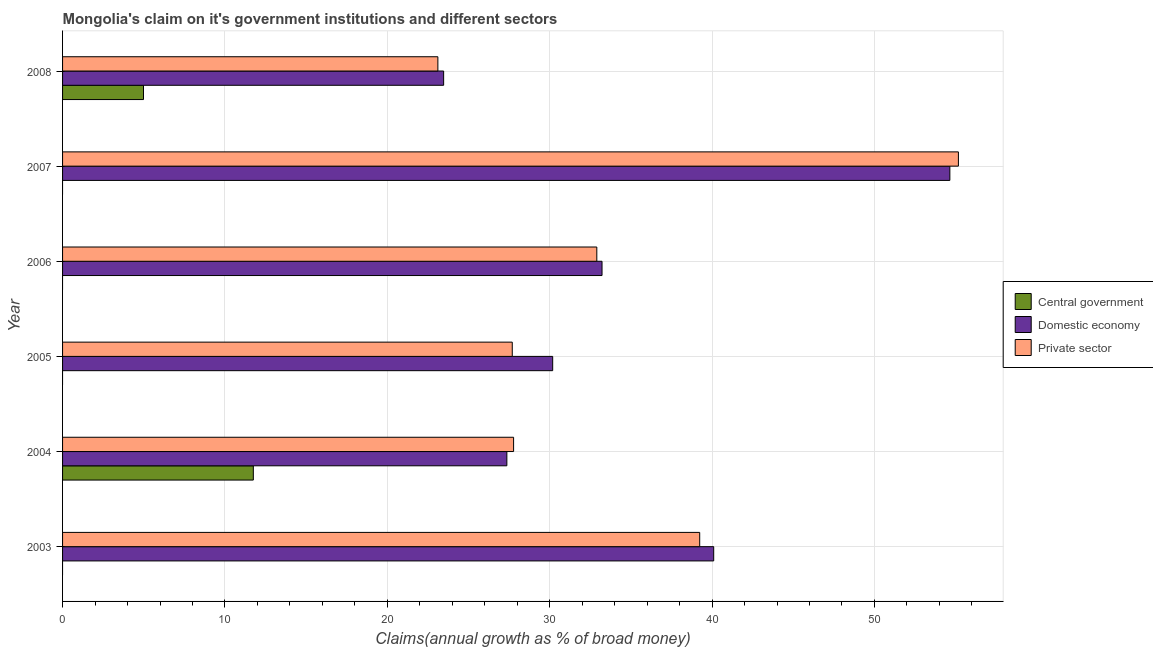How many different coloured bars are there?
Ensure brevity in your answer.  3. Are the number of bars per tick equal to the number of legend labels?
Your answer should be very brief. No. Are the number of bars on each tick of the Y-axis equal?
Your answer should be compact. No. How many bars are there on the 1st tick from the top?
Give a very brief answer. 3. How many bars are there on the 6th tick from the bottom?
Keep it short and to the point. 3. What is the label of the 3rd group of bars from the top?
Make the answer very short. 2006. What is the percentage of claim on the private sector in 2008?
Make the answer very short. 23.11. Across all years, what is the maximum percentage of claim on the central government?
Your answer should be compact. 11.75. Across all years, what is the minimum percentage of claim on the private sector?
Offer a terse response. 23.11. In which year was the percentage of claim on the domestic economy maximum?
Provide a succinct answer. 2007. What is the total percentage of claim on the central government in the graph?
Your answer should be compact. 16.73. What is the difference between the percentage of claim on the domestic economy in 2005 and that in 2008?
Ensure brevity in your answer.  6.71. What is the difference between the percentage of claim on the private sector in 2007 and the percentage of claim on the domestic economy in 2005?
Keep it short and to the point. 24.99. What is the average percentage of claim on the private sector per year?
Your answer should be compact. 34.32. In the year 2007, what is the difference between the percentage of claim on the private sector and percentage of claim on the domestic economy?
Your answer should be very brief. 0.53. In how many years, is the percentage of claim on the private sector greater than 8 %?
Keep it short and to the point. 6. What is the ratio of the percentage of claim on the domestic economy in 2003 to that in 2008?
Give a very brief answer. 1.71. What is the difference between the highest and the second highest percentage of claim on the private sector?
Offer a very short reply. 15.93. What is the difference between the highest and the lowest percentage of claim on the central government?
Ensure brevity in your answer.  11.75. Is it the case that in every year, the sum of the percentage of claim on the central government and percentage of claim on the domestic economy is greater than the percentage of claim on the private sector?
Your response must be concise. No. How many bars are there?
Ensure brevity in your answer.  14. Are all the bars in the graph horizontal?
Give a very brief answer. Yes. How many years are there in the graph?
Offer a very short reply. 6. Where does the legend appear in the graph?
Offer a terse response. Center right. How many legend labels are there?
Ensure brevity in your answer.  3. How are the legend labels stacked?
Give a very brief answer. Vertical. What is the title of the graph?
Offer a terse response. Mongolia's claim on it's government institutions and different sectors. Does "Grants" appear as one of the legend labels in the graph?
Your answer should be compact. No. What is the label or title of the X-axis?
Give a very brief answer. Claims(annual growth as % of broad money). What is the Claims(annual growth as % of broad money) of Domestic economy in 2003?
Your response must be concise. 40.1. What is the Claims(annual growth as % of broad money) in Private sector in 2003?
Your response must be concise. 39.24. What is the Claims(annual growth as % of broad money) in Central government in 2004?
Your answer should be very brief. 11.75. What is the Claims(annual growth as % of broad money) in Domestic economy in 2004?
Make the answer very short. 27.36. What is the Claims(annual growth as % of broad money) in Private sector in 2004?
Your response must be concise. 27.78. What is the Claims(annual growth as % of broad money) in Central government in 2005?
Provide a succinct answer. 0. What is the Claims(annual growth as % of broad money) in Domestic economy in 2005?
Offer a terse response. 30.18. What is the Claims(annual growth as % of broad money) of Private sector in 2005?
Your answer should be compact. 27.69. What is the Claims(annual growth as % of broad money) in Domestic economy in 2006?
Provide a short and direct response. 33.22. What is the Claims(annual growth as % of broad money) in Private sector in 2006?
Provide a succinct answer. 32.9. What is the Claims(annual growth as % of broad money) of Central government in 2007?
Provide a short and direct response. 0. What is the Claims(annual growth as % of broad money) in Domestic economy in 2007?
Your answer should be compact. 54.64. What is the Claims(annual growth as % of broad money) in Private sector in 2007?
Keep it short and to the point. 55.17. What is the Claims(annual growth as % of broad money) in Central government in 2008?
Give a very brief answer. 4.98. What is the Claims(annual growth as % of broad money) in Domestic economy in 2008?
Your response must be concise. 23.47. What is the Claims(annual growth as % of broad money) in Private sector in 2008?
Provide a succinct answer. 23.11. Across all years, what is the maximum Claims(annual growth as % of broad money) in Central government?
Provide a short and direct response. 11.75. Across all years, what is the maximum Claims(annual growth as % of broad money) of Domestic economy?
Your answer should be very brief. 54.64. Across all years, what is the maximum Claims(annual growth as % of broad money) of Private sector?
Make the answer very short. 55.17. Across all years, what is the minimum Claims(annual growth as % of broad money) of Domestic economy?
Keep it short and to the point. 23.47. Across all years, what is the minimum Claims(annual growth as % of broad money) of Private sector?
Your response must be concise. 23.11. What is the total Claims(annual growth as % of broad money) of Central government in the graph?
Provide a short and direct response. 16.73. What is the total Claims(annual growth as % of broad money) of Domestic economy in the graph?
Ensure brevity in your answer.  208.98. What is the total Claims(annual growth as % of broad money) in Private sector in the graph?
Provide a succinct answer. 205.89. What is the difference between the Claims(annual growth as % of broad money) of Domestic economy in 2003 and that in 2004?
Your answer should be very brief. 12.74. What is the difference between the Claims(annual growth as % of broad money) in Private sector in 2003 and that in 2004?
Provide a short and direct response. 11.46. What is the difference between the Claims(annual growth as % of broad money) of Domestic economy in 2003 and that in 2005?
Offer a terse response. 9.92. What is the difference between the Claims(annual growth as % of broad money) of Private sector in 2003 and that in 2005?
Make the answer very short. 11.54. What is the difference between the Claims(annual growth as % of broad money) of Domestic economy in 2003 and that in 2006?
Your response must be concise. 6.88. What is the difference between the Claims(annual growth as % of broad money) in Private sector in 2003 and that in 2006?
Your answer should be compact. 6.34. What is the difference between the Claims(annual growth as % of broad money) in Domestic economy in 2003 and that in 2007?
Your response must be concise. -14.54. What is the difference between the Claims(annual growth as % of broad money) of Private sector in 2003 and that in 2007?
Give a very brief answer. -15.93. What is the difference between the Claims(annual growth as % of broad money) in Domestic economy in 2003 and that in 2008?
Your response must be concise. 16.63. What is the difference between the Claims(annual growth as % of broad money) of Private sector in 2003 and that in 2008?
Give a very brief answer. 16.13. What is the difference between the Claims(annual growth as % of broad money) of Domestic economy in 2004 and that in 2005?
Provide a succinct answer. -2.82. What is the difference between the Claims(annual growth as % of broad money) in Private sector in 2004 and that in 2005?
Provide a succinct answer. 0.08. What is the difference between the Claims(annual growth as % of broad money) of Domestic economy in 2004 and that in 2006?
Give a very brief answer. -5.86. What is the difference between the Claims(annual growth as % of broad money) of Private sector in 2004 and that in 2006?
Offer a very short reply. -5.13. What is the difference between the Claims(annual growth as % of broad money) in Domestic economy in 2004 and that in 2007?
Provide a succinct answer. -27.28. What is the difference between the Claims(annual growth as % of broad money) of Private sector in 2004 and that in 2007?
Give a very brief answer. -27.39. What is the difference between the Claims(annual growth as % of broad money) of Central government in 2004 and that in 2008?
Your answer should be very brief. 6.76. What is the difference between the Claims(annual growth as % of broad money) of Domestic economy in 2004 and that in 2008?
Keep it short and to the point. 3.89. What is the difference between the Claims(annual growth as % of broad money) in Private sector in 2004 and that in 2008?
Your answer should be very brief. 4.66. What is the difference between the Claims(annual growth as % of broad money) of Domestic economy in 2005 and that in 2006?
Ensure brevity in your answer.  -3.04. What is the difference between the Claims(annual growth as % of broad money) in Private sector in 2005 and that in 2006?
Ensure brevity in your answer.  -5.21. What is the difference between the Claims(annual growth as % of broad money) in Domestic economy in 2005 and that in 2007?
Provide a short and direct response. -24.46. What is the difference between the Claims(annual growth as % of broad money) in Private sector in 2005 and that in 2007?
Your answer should be very brief. -27.48. What is the difference between the Claims(annual growth as % of broad money) in Domestic economy in 2005 and that in 2008?
Your answer should be very brief. 6.71. What is the difference between the Claims(annual growth as % of broad money) in Private sector in 2005 and that in 2008?
Offer a terse response. 4.58. What is the difference between the Claims(annual growth as % of broad money) of Domestic economy in 2006 and that in 2007?
Give a very brief answer. -21.42. What is the difference between the Claims(annual growth as % of broad money) of Private sector in 2006 and that in 2007?
Offer a terse response. -22.27. What is the difference between the Claims(annual growth as % of broad money) in Domestic economy in 2006 and that in 2008?
Keep it short and to the point. 9.75. What is the difference between the Claims(annual growth as % of broad money) in Private sector in 2006 and that in 2008?
Keep it short and to the point. 9.79. What is the difference between the Claims(annual growth as % of broad money) in Domestic economy in 2007 and that in 2008?
Provide a succinct answer. 31.18. What is the difference between the Claims(annual growth as % of broad money) of Private sector in 2007 and that in 2008?
Provide a succinct answer. 32.06. What is the difference between the Claims(annual growth as % of broad money) in Domestic economy in 2003 and the Claims(annual growth as % of broad money) in Private sector in 2004?
Provide a short and direct response. 12.32. What is the difference between the Claims(annual growth as % of broad money) of Domestic economy in 2003 and the Claims(annual growth as % of broad money) of Private sector in 2005?
Your response must be concise. 12.41. What is the difference between the Claims(annual growth as % of broad money) of Domestic economy in 2003 and the Claims(annual growth as % of broad money) of Private sector in 2006?
Provide a succinct answer. 7.2. What is the difference between the Claims(annual growth as % of broad money) in Domestic economy in 2003 and the Claims(annual growth as % of broad money) in Private sector in 2007?
Your answer should be compact. -15.07. What is the difference between the Claims(annual growth as % of broad money) in Domestic economy in 2003 and the Claims(annual growth as % of broad money) in Private sector in 2008?
Offer a very short reply. 16.99. What is the difference between the Claims(annual growth as % of broad money) of Central government in 2004 and the Claims(annual growth as % of broad money) of Domestic economy in 2005?
Keep it short and to the point. -18.44. What is the difference between the Claims(annual growth as % of broad money) of Central government in 2004 and the Claims(annual growth as % of broad money) of Private sector in 2005?
Provide a succinct answer. -15.95. What is the difference between the Claims(annual growth as % of broad money) of Domestic economy in 2004 and the Claims(annual growth as % of broad money) of Private sector in 2005?
Make the answer very short. -0.33. What is the difference between the Claims(annual growth as % of broad money) in Central government in 2004 and the Claims(annual growth as % of broad money) in Domestic economy in 2006?
Offer a very short reply. -21.47. What is the difference between the Claims(annual growth as % of broad money) of Central government in 2004 and the Claims(annual growth as % of broad money) of Private sector in 2006?
Your answer should be compact. -21.15. What is the difference between the Claims(annual growth as % of broad money) of Domestic economy in 2004 and the Claims(annual growth as % of broad money) of Private sector in 2006?
Your answer should be very brief. -5.54. What is the difference between the Claims(annual growth as % of broad money) in Central government in 2004 and the Claims(annual growth as % of broad money) in Domestic economy in 2007?
Make the answer very short. -42.9. What is the difference between the Claims(annual growth as % of broad money) of Central government in 2004 and the Claims(annual growth as % of broad money) of Private sector in 2007?
Your answer should be compact. -43.42. What is the difference between the Claims(annual growth as % of broad money) of Domestic economy in 2004 and the Claims(annual growth as % of broad money) of Private sector in 2007?
Make the answer very short. -27.81. What is the difference between the Claims(annual growth as % of broad money) of Central government in 2004 and the Claims(annual growth as % of broad money) of Domestic economy in 2008?
Make the answer very short. -11.72. What is the difference between the Claims(annual growth as % of broad money) in Central government in 2004 and the Claims(annual growth as % of broad money) in Private sector in 2008?
Your answer should be very brief. -11.36. What is the difference between the Claims(annual growth as % of broad money) in Domestic economy in 2004 and the Claims(annual growth as % of broad money) in Private sector in 2008?
Offer a terse response. 4.25. What is the difference between the Claims(annual growth as % of broad money) of Domestic economy in 2005 and the Claims(annual growth as % of broad money) of Private sector in 2006?
Make the answer very short. -2.72. What is the difference between the Claims(annual growth as % of broad money) in Domestic economy in 2005 and the Claims(annual growth as % of broad money) in Private sector in 2007?
Keep it short and to the point. -24.99. What is the difference between the Claims(annual growth as % of broad money) of Domestic economy in 2005 and the Claims(annual growth as % of broad money) of Private sector in 2008?
Keep it short and to the point. 7.07. What is the difference between the Claims(annual growth as % of broad money) in Domestic economy in 2006 and the Claims(annual growth as % of broad money) in Private sector in 2007?
Your answer should be very brief. -21.95. What is the difference between the Claims(annual growth as % of broad money) in Domestic economy in 2006 and the Claims(annual growth as % of broad money) in Private sector in 2008?
Offer a very short reply. 10.11. What is the difference between the Claims(annual growth as % of broad money) of Domestic economy in 2007 and the Claims(annual growth as % of broad money) of Private sector in 2008?
Provide a short and direct response. 31.53. What is the average Claims(annual growth as % of broad money) in Central government per year?
Offer a terse response. 2.79. What is the average Claims(annual growth as % of broad money) in Domestic economy per year?
Your response must be concise. 34.83. What is the average Claims(annual growth as % of broad money) in Private sector per year?
Ensure brevity in your answer.  34.32. In the year 2003, what is the difference between the Claims(annual growth as % of broad money) of Domestic economy and Claims(annual growth as % of broad money) of Private sector?
Your response must be concise. 0.86. In the year 2004, what is the difference between the Claims(annual growth as % of broad money) of Central government and Claims(annual growth as % of broad money) of Domestic economy?
Provide a short and direct response. -15.61. In the year 2004, what is the difference between the Claims(annual growth as % of broad money) in Central government and Claims(annual growth as % of broad money) in Private sector?
Make the answer very short. -16.03. In the year 2004, what is the difference between the Claims(annual growth as % of broad money) in Domestic economy and Claims(annual growth as % of broad money) in Private sector?
Your answer should be compact. -0.41. In the year 2005, what is the difference between the Claims(annual growth as % of broad money) of Domestic economy and Claims(annual growth as % of broad money) of Private sector?
Provide a short and direct response. 2.49. In the year 2006, what is the difference between the Claims(annual growth as % of broad money) in Domestic economy and Claims(annual growth as % of broad money) in Private sector?
Ensure brevity in your answer.  0.32. In the year 2007, what is the difference between the Claims(annual growth as % of broad money) of Domestic economy and Claims(annual growth as % of broad money) of Private sector?
Your response must be concise. -0.53. In the year 2008, what is the difference between the Claims(annual growth as % of broad money) in Central government and Claims(annual growth as % of broad money) in Domestic economy?
Make the answer very short. -18.48. In the year 2008, what is the difference between the Claims(annual growth as % of broad money) of Central government and Claims(annual growth as % of broad money) of Private sector?
Give a very brief answer. -18.13. In the year 2008, what is the difference between the Claims(annual growth as % of broad money) in Domestic economy and Claims(annual growth as % of broad money) in Private sector?
Your answer should be very brief. 0.36. What is the ratio of the Claims(annual growth as % of broad money) of Domestic economy in 2003 to that in 2004?
Your answer should be very brief. 1.47. What is the ratio of the Claims(annual growth as % of broad money) of Private sector in 2003 to that in 2004?
Provide a short and direct response. 1.41. What is the ratio of the Claims(annual growth as % of broad money) in Domestic economy in 2003 to that in 2005?
Offer a terse response. 1.33. What is the ratio of the Claims(annual growth as % of broad money) of Private sector in 2003 to that in 2005?
Offer a very short reply. 1.42. What is the ratio of the Claims(annual growth as % of broad money) in Domestic economy in 2003 to that in 2006?
Your answer should be very brief. 1.21. What is the ratio of the Claims(annual growth as % of broad money) of Private sector in 2003 to that in 2006?
Make the answer very short. 1.19. What is the ratio of the Claims(annual growth as % of broad money) of Domestic economy in 2003 to that in 2007?
Your answer should be compact. 0.73. What is the ratio of the Claims(annual growth as % of broad money) in Private sector in 2003 to that in 2007?
Your response must be concise. 0.71. What is the ratio of the Claims(annual growth as % of broad money) in Domestic economy in 2003 to that in 2008?
Keep it short and to the point. 1.71. What is the ratio of the Claims(annual growth as % of broad money) of Private sector in 2003 to that in 2008?
Your answer should be very brief. 1.7. What is the ratio of the Claims(annual growth as % of broad money) in Domestic economy in 2004 to that in 2005?
Give a very brief answer. 0.91. What is the ratio of the Claims(annual growth as % of broad money) in Domestic economy in 2004 to that in 2006?
Offer a very short reply. 0.82. What is the ratio of the Claims(annual growth as % of broad money) in Private sector in 2004 to that in 2006?
Make the answer very short. 0.84. What is the ratio of the Claims(annual growth as % of broad money) of Domestic economy in 2004 to that in 2007?
Ensure brevity in your answer.  0.5. What is the ratio of the Claims(annual growth as % of broad money) of Private sector in 2004 to that in 2007?
Provide a short and direct response. 0.5. What is the ratio of the Claims(annual growth as % of broad money) of Central government in 2004 to that in 2008?
Your answer should be compact. 2.36. What is the ratio of the Claims(annual growth as % of broad money) in Domestic economy in 2004 to that in 2008?
Give a very brief answer. 1.17. What is the ratio of the Claims(annual growth as % of broad money) in Private sector in 2004 to that in 2008?
Provide a short and direct response. 1.2. What is the ratio of the Claims(annual growth as % of broad money) in Domestic economy in 2005 to that in 2006?
Give a very brief answer. 0.91. What is the ratio of the Claims(annual growth as % of broad money) of Private sector in 2005 to that in 2006?
Keep it short and to the point. 0.84. What is the ratio of the Claims(annual growth as % of broad money) in Domestic economy in 2005 to that in 2007?
Your answer should be compact. 0.55. What is the ratio of the Claims(annual growth as % of broad money) of Private sector in 2005 to that in 2007?
Ensure brevity in your answer.  0.5. What is the ratio of the Claims(annual growth as % of broad money) of Domestic economy in 2005 to that in 2008?
Provide a short and direct response. 1.29. What is the ratio of the Claims(annual growth as % of broad money) in Private sector in 2005 to that in 2008?
Your answer should be compact. 1.2. What is the ratio of the Claims(annual growth as % of broad money) of Domestic economy in 2006 to that in 2007?
Your answer should be compact. 0.61. What is the ratio of the Claims(annual growth as % of broad money) in Private sector in 2006 to that in 2007?
Your answer should be very brief. 0.6. What is the ratio of the Claims(annual growth as % of broad money) in Domestic economy in 2006 to that in 2008?
Give a very brief answer. 1.42. What is the ratio of the Claims(annual growth as % of broad money) of Private sector in 2006 to that in 2008?
Offer a very short reply. 1.42. What is the ratio of the Claims(annual growth as % of broad money) of Domestic economy in 2007 to that in 2008?
Ensure brevity in your answer.  2.33. What is the ratio of the Claims(annual growth as % of broad money) in Private sector in 2007 to that in 2008?
Provide a succinct answer. 2.39. What is the difference between the highest and the second highest Claims(annual growth as % of broad money) in Domestic economy?
Keep it short and to the point. 14.54. What is the difference between the highest and the second highest Claims(annual growth as % of broad money) in Private sector?
Your answer should be very brief. 15.93. What is the difference between the highest and the lowest Claims(annual growth as % of broad money) in Central government?
Provide a succinct answer. 11.75. What is the difference between the highest and the lowest Claims(annual growth as % of broad money) in Domestic economy?
Provide a succinct answer. 31.18. What is the difference between the highest and the lowest Claims(annual growth as % of broad money) of Private sector?
Provide a succinct answer. 32.06. 